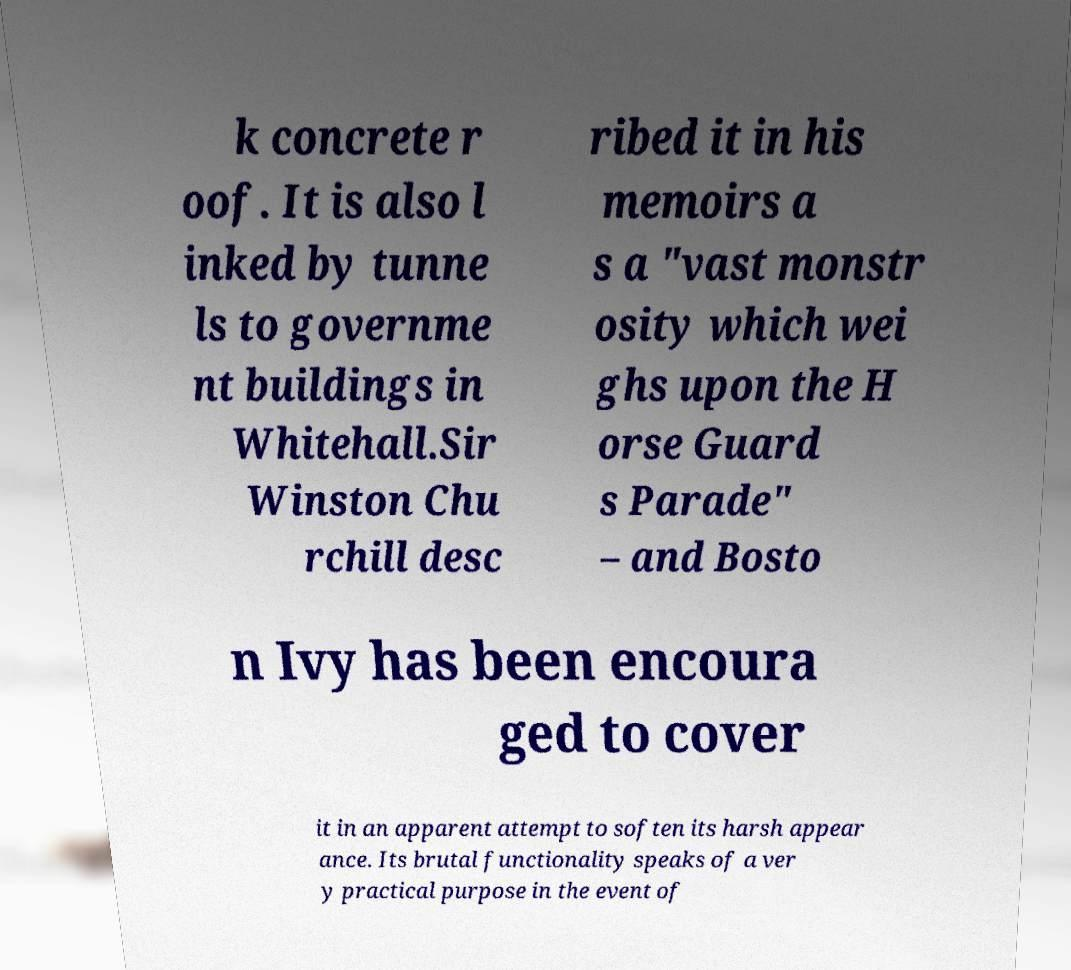For documentation purposes, I need the text within this image transcribed. Could you provide that? k concrete r oof. It is also l inked by tunne ls to governme nt buildings in Whitehall.Sir Winston Chu rchill desc ribed it in his memoirs a s a "vast monstr osity which wei ghs upon the H orse Guard s Parade" – and Bosto n Ivy has been encoura ged to cover it in an apparent attempt to soften its harsh appear ance. Its brutal functionality speaks of a ver y practical purpose in the event of 